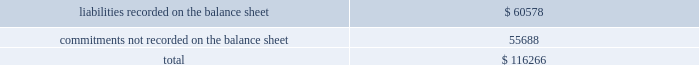( e ) total contractual obligations are made up of the following components .
( in millions ) .
Off-balance sheet arrangements as of december 31 , 2015 , we did not have any material off-balance sheet arrangements that are reasonably likely to have a current or future effect on our financial condition , results of operations , liquidity , capital expenditures or capital resources .
Recent accounting pronouncements see note 3 to each of comcast 2019s and nbcuniversal 2019s consolidated financial statements for additional information related to recent accounting pronouncements .
Critical accounting judgments and estimates the preparation of our consolidated financial statements requires us to make estimates that affect the reported amounts of assets , liabilities , revenue and expenses , and the related disclosure of contingent assets and contingent liabilities .
We base our judgments on our historical experience and on various other assump- tions that we believe are reasonable under the circumstances , the results of which form the basis for making estimates about the carrying value of assets and liabilities that are not readily apparent from other sources .
Actual results may differ from these estimates under different assumptions or conditions .
We believe our judgments and related estimates associated with the valuation and impairment testing of our cable franchise rights and the accounting for film and television costs are critical in the preparation of our consolidated financial statements .
Management has discussed the development and selection of these crit- ical accounting judgments and estimates with the audit committee of our board of directors , and the audit committee has reviewed our disclosures relating to them , which are presented below .
See notes 9 and 6 to comcast 2019s consolidated financial statements for a discussion of our accounting policies with respect to these items .
Valuation and impairment testing of cable franchise rights our largest asset , our cable franchise rights , results from agreements we have with state and local govern- ments that allow us to construct and operate a cable business within a specified geographic area .
The value of a franchise is derived from the economic benefits we receive from the right to solicit new customers and to market new services , such as advanced video services and high-speed internet and voice services , in a particular service area .
The amounts we record for cable franchise rights are primarily a result of cable system acquisitions .
Typically when we acquire a cable system , the most significant asset we record is the value of the cable franchise rights .
Often these cable system acquisitions include multiple franchise areas .
We cur- rently serve approximately 6400 franchise areas in the united states .
We have concluded that our cable franchise rights have an indefinite useful life since there are no legal , regu- latory , contractual , competitive , economic or other factors which limit the period over which these rights will contribute to our cash flows .
Accordingly , we do not amortize our cable franchise rights but assess the carry- ing value of our cable franchise rights annually , or more frequently whenever events or changes in circumstances indicate that the carrying amount may exceed the fair value ( 201cimpairment testing 201d ) .
67 comcast 2015 annual report on form 10-k .
What was the ratio of the total contractual obligations for the liabilities recorded on the balance sheet to the commitments not recorded on the balance sheet? 
Computations: (60578 / 55688)
Answer: 1.08781. 